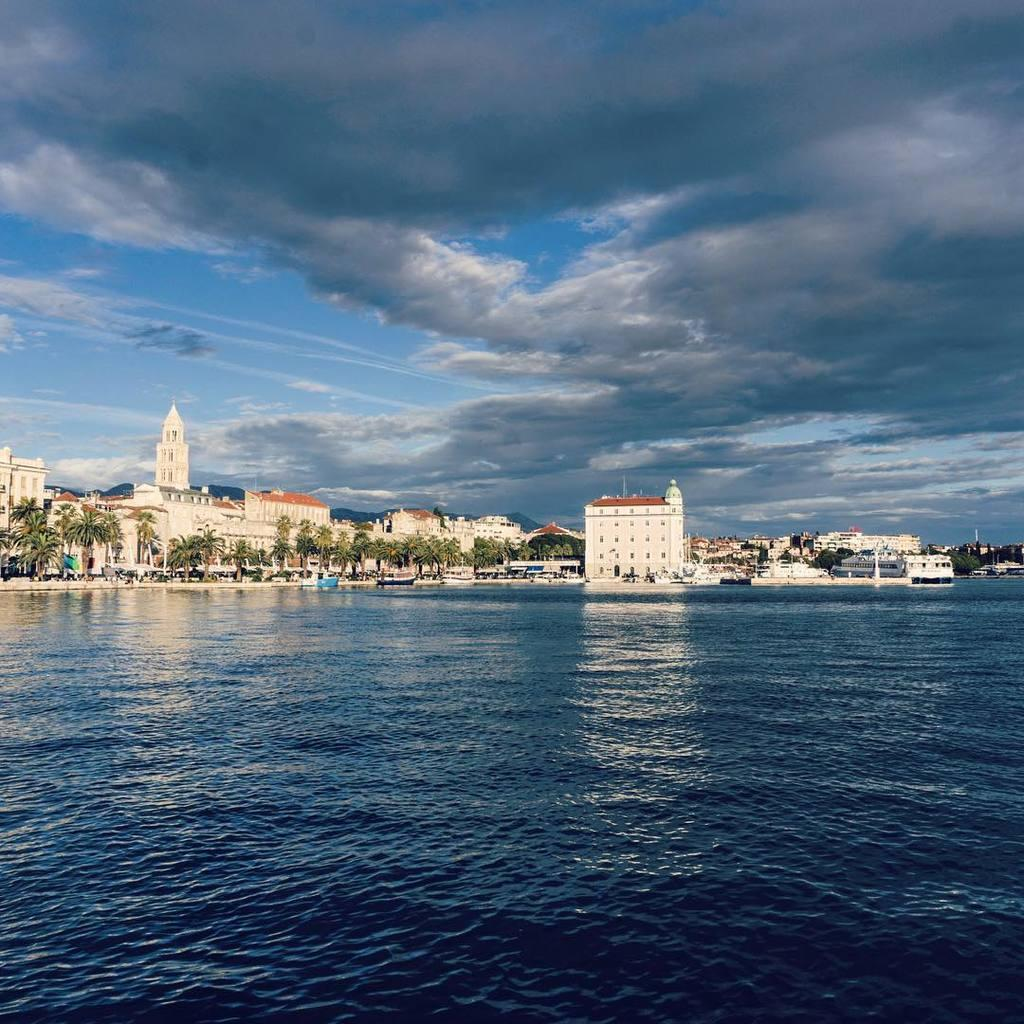What is the primary element visible in the image? There is water in the image. What structures can be seen in the image? There are buildings in the image. What type of vegetation is present in the image? There are trees in the image. How would you describe the sky in the image? The sky is blue and cloudy in the image. What invention is being demonstrated by the deer in the image? There is no deer present in the image, and therefore no invention can be demonstrated. Is there a cap visible on any of the trees in the image? There is no cap visible on any of the trees in the image. 